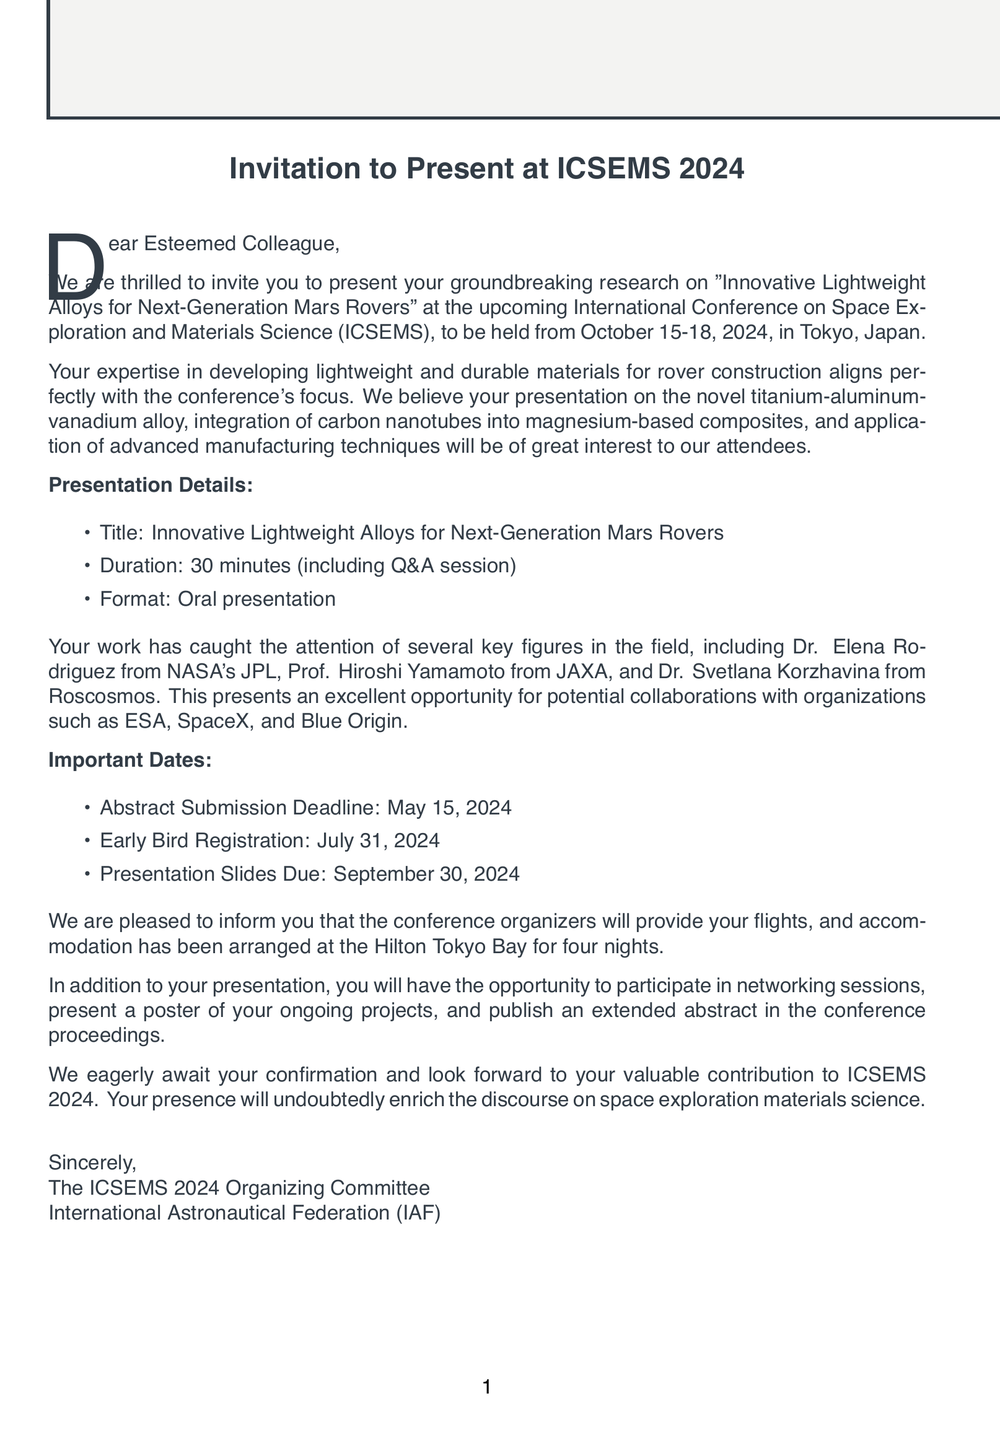what is the name of the conference? The name of the conference is explicitly stated in the document, which is the International Conference on Space Exploration and Materials Science.
Answer: International Conference on Space Exploration and Materials Science (ICSEMS) when is the conference scheduled? The date of the conference is provided in the document, specifying when it will take place.
Answer: October 15-18, 2024 who organizes the conference? The organizer of the conference is mentioned in the document, providing the name of the organizing body.
Answer: International Astronautical Federation (IAF) what is the title of the presentation? The title of the presentation is clearly indicated in the document, reflecting the focus of the research being shared.
Answer: Innovative Lightweight Alloys for Next-Generation Mars Rovers how long is the presentation? The duration of the presentation is explicitly stated in the document, providing insight into how long attendees can expect it to last.
Answer: 30 minutes which hotel is the accommodation arranged at? The name of the hotel where accommodation has been arranged is specified in the document.
Answer: Hilton Tokyo Bay what is the abstract submission deadline? The explicit deadline for abstract submission is outlined in the document, offering a specific date for this task.
Answer: May 15, 2024 what opportunities will attendees have besides the presentation? The document mentions additional opportunities for engagement at the conference, which reflects the variety of activities available to participants.
Answer: Networking session with industry leaders who are some relevant audience members? The document lists key figures in the field who will be present at the conference, indicating important attendees.
Answer: Dr. Elena Rodriguez, Prof. Hiroshi Yamamoto, Dr. Svetlana Korzhavina 